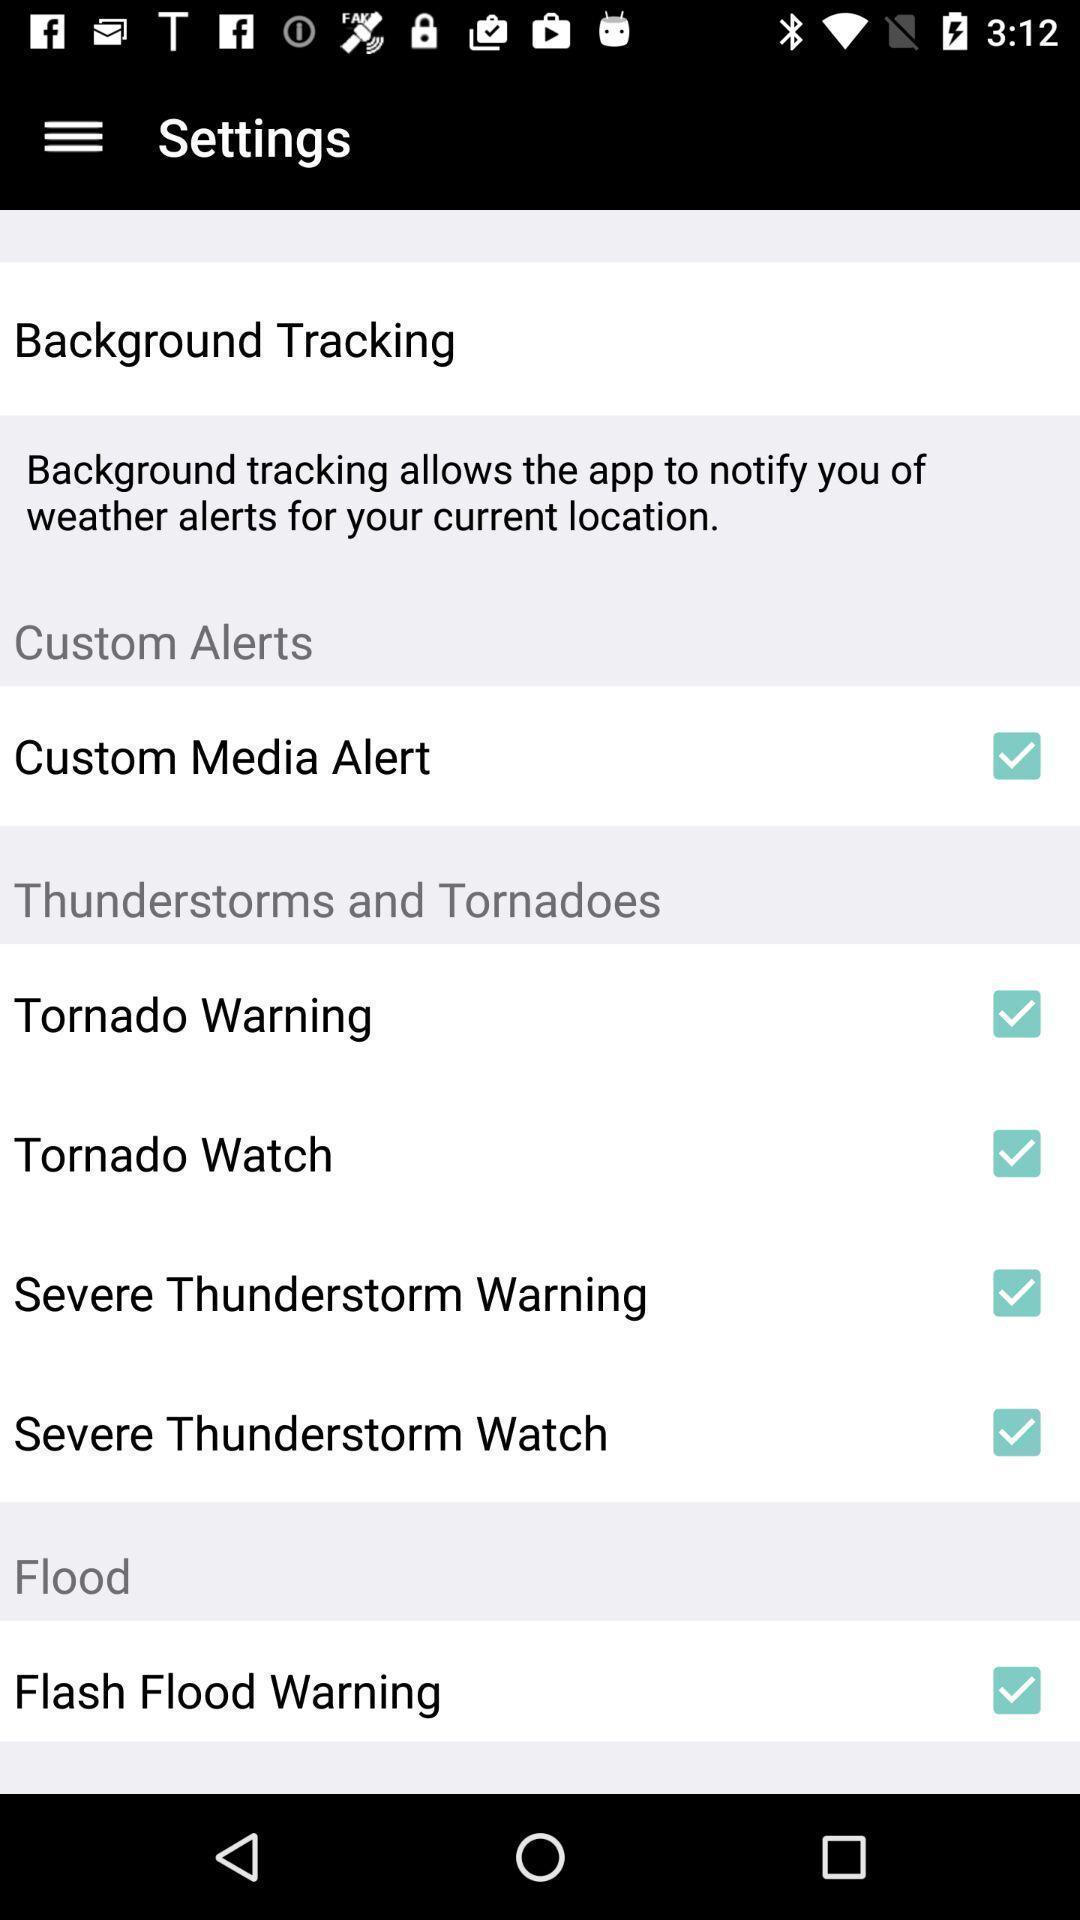Describe the key features of this screenshot. Page showing list of different setting options. 